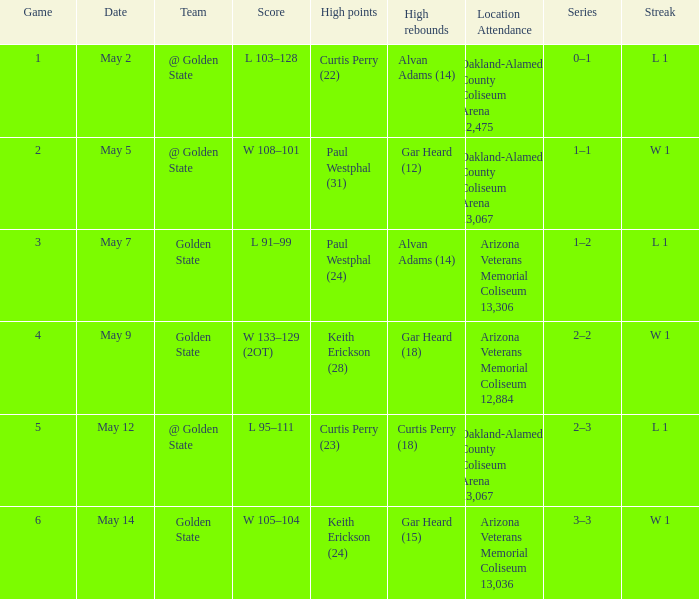How many games had they won or lost in a row on May 9? W 1. 